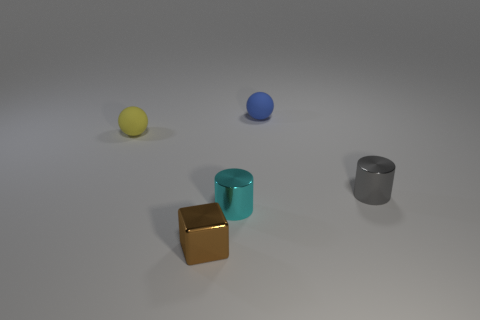Add 2 big shiny cylinders. How many objects exist? 7 Subtract all cubes. How many objects are left? 4 Subtract 0 purple cylinders. How many objects are left? 5 Subtract all brown things. Subtract all small cylinders. How many objects are left? 2 Add 4 cubes. How many cubes are left? 5 Add 4 metallic objects. How many metallic objects exist? 7 